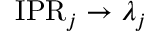<formula> <loc_0><loc_0><loc_500><loc_500>I P R _ { j } \rightarrow \lambda _ { j }</formula> 